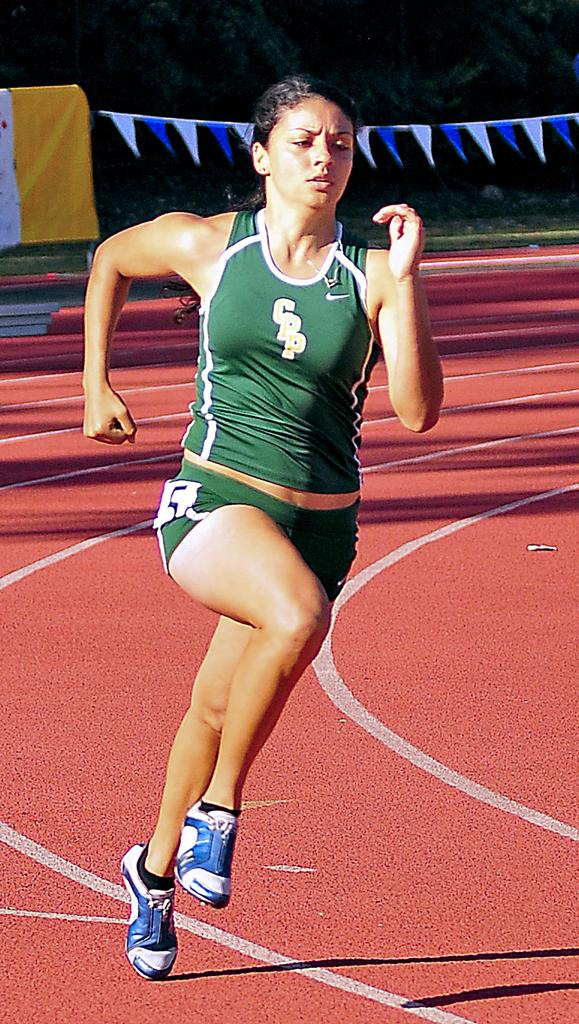<image>
Summarize the visual content of the image. A track athlete for CPP is rounding the turn in a race. 